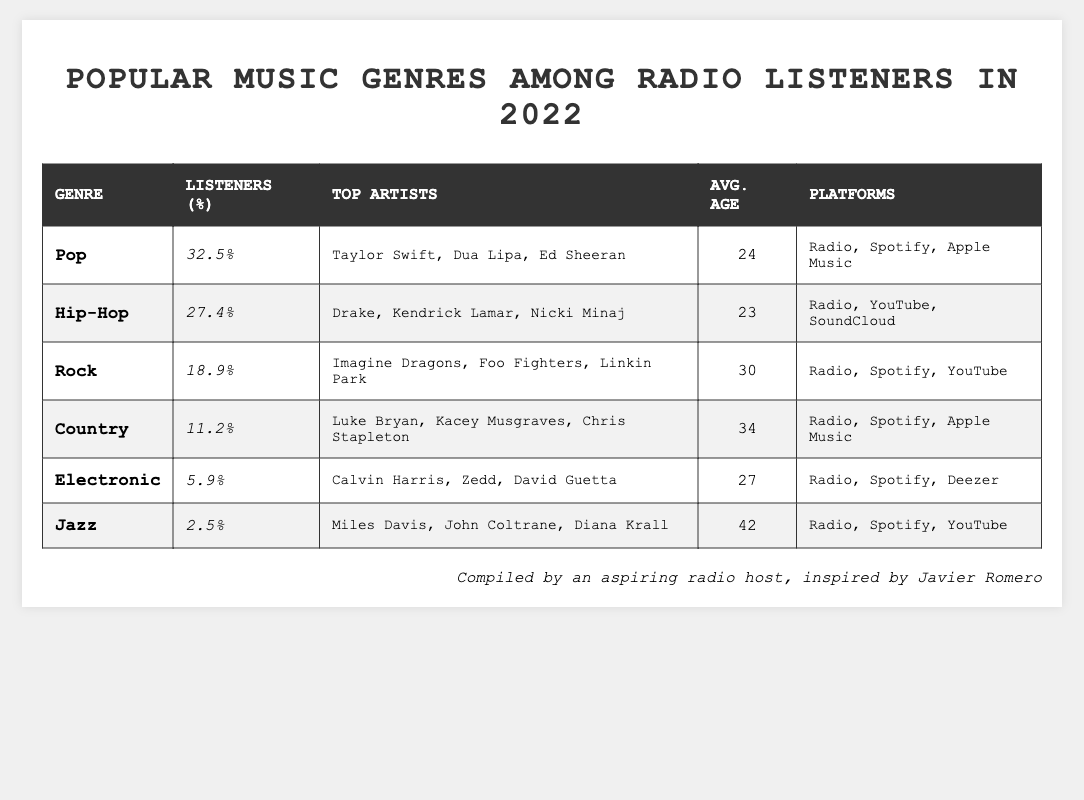What is the percentage of listeners for the Pop genre? According to the table, the percentage of listeners for the Pop genre is listed directly next to it, which shows a value of 32.5%.
Answer: 32.5% Which genre has the highest percentage of listeners? By checking all the genres in the table, Pop has the highest percentage of listeners at 32.5%.
Answer: Pop What are the top artists for the Hip-Hop genre? The table lists the top artists for the Hip-Hop genre clearly, which are Drake, Kendrick Lamar, and Nicki Minaj.
Answer: Drake, Kendrick Lamar, Nicki Minaj What is the average age of listeners for the Rock genre? The table provides the average age of listeners for each genre, showing that the average age for Rock listeners is 30 years old.
Answer: 30 How many more percentage points of listeners does Pop have compared to Jazz? The percentage of listeners for Pop is 32.5% and for Jazz it is 2.5%. When you subtract 2.5 from 32.5, the answer is 30.
Answer: 30 Is the average age of listeners for Country genre older than that of Pop genre? The average age for Country listeners is 34, while for Pop it is 24. Since 34 is greater than 24, the statement is true.
Answer: Yes What genre has the lowest percentage of listeners, and what is that percentage? By reviewing the percentages across all genres in the table, Jazz has the lowest percentage at 2.5%.
Answer: Jazz, 2.5% If you combine the listeners of Country and Electronic genres, what is their total percentage? The percentage of listeners for Country is 11.2% and for Electronic is 5.9%. By adding these two percentages together (11.2 + 5.9), the total is 17.1%.
Answer: 17.1% Which genre has the oldest average age of listeners and what is that age? The average ages for all genres are reviewed, showing that Jazz has the highest average age at 42 years old.
Answer: Jazz, 42 What are the listening platforms for the Electronic genre? The table explicitly lists the platforms for the Electronic genre, which include Radio, Spotify, and Deezer.
Answer: Radio, Spotify, Deezer 